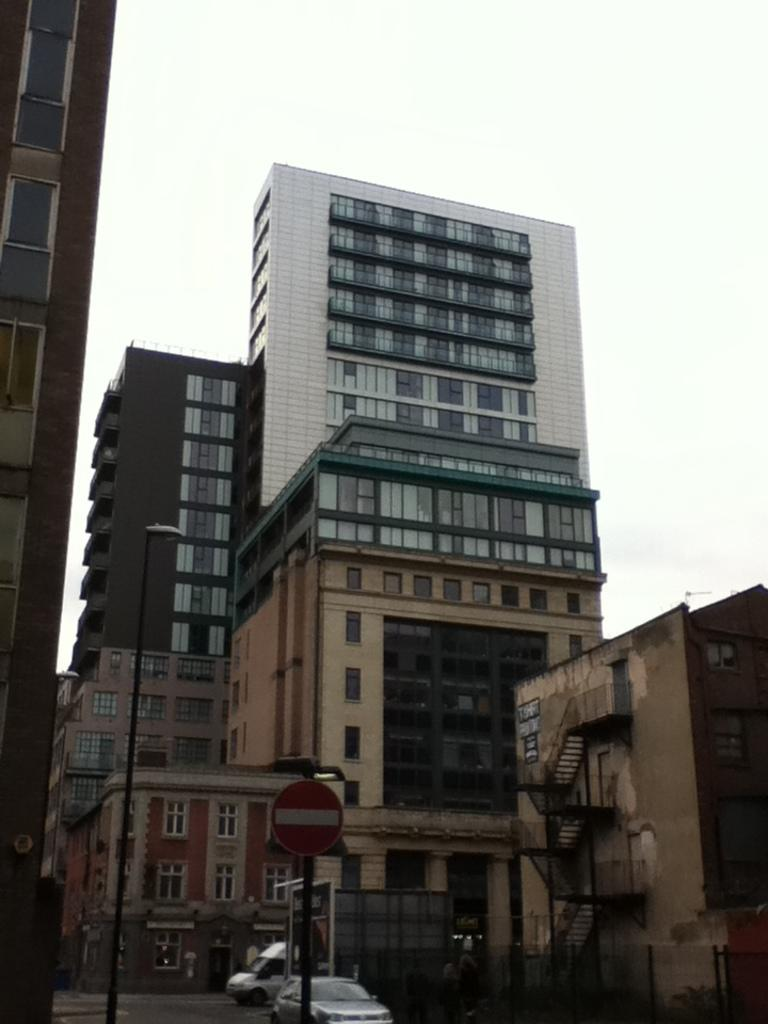What type of structures can be seen in the image? There are buildings in the image. What is located near the buildings? There is a sign board and a street light in the image. What is visible in the sky in the image? The sky is visible in the image. What can be seen moving on the road in the image? There are vehicles on the road in the image. What type of skate is being used by the band in the image? There is no skate or band present in the image. What type of tank is visible in the image? There is no tank present in the image. 